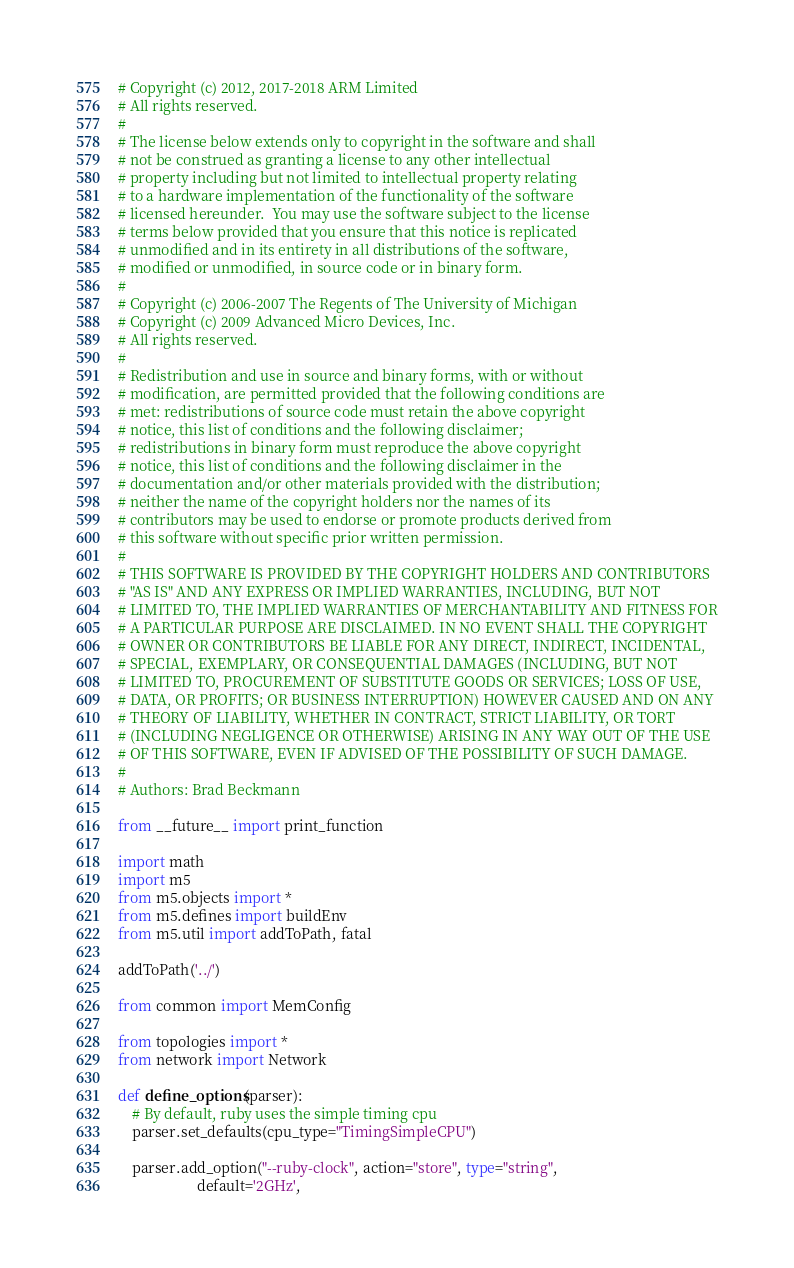Convert code to text. <code><loc_0><loc_0><loc_500><loc_500><_Python_># Copyright (c) 2012, 2017-2018 ARM Limited
# All rights reserved.
#
# The license below extends only to copyright in the software and shall
# not be construed as granting a license to any other intellectual
# property including but not limited to intellectual property relating
# to a hardware implementation of the functionality of the software
# licensed hereunder.  You may use the software subject to the license
# terms below provided that you ensure that this notice is replicated
# unmodified and in its entirety in all distributions of the software,
# modified or unmodified, in source code or in binary form.
#
# Copyright (c) 2006-2007 The Regents of The University of Michigan
# Copyright (c) 2009 Advanced Micro Devices, Inc.
# All rights reserved.
#
# Redistribution and use in source and binary forms, with or without
# modification, are permitted provided that the following conditions are
# met: redistributions of source code must retain the above copyright
# notice, this list of conditions and the following disclaimer;
# redistributions in binary form must reproduce the above copyright
# notice, this list of conditions and the following disclaimer in the
# documentation and/or other materials provided with the distribution;
# neither the name of the copyright holders nor the names of its
# contributors may be used to endorse or promote products derived from
# this software without specific prior written permission.
#
# THIS SOFTWARE IS PROVIDED BY THE COPYRIGHT HOLDERS AND CONTRIBUTORS
# "AS IS" AND ANY EXPRESS OR IMPLIED WARRANTIES, INCLUDING, BUT NOT
# LIMITED TO, THE IMPLIED WARRANTIES OF MERCHANTABILITY AND FITNESS FOR
# A PARTICULAR PURPOSE ARE DISCLAIMED. IN NO EVENT SHALL THE COPYRIGHT
# OWNER OR CONTRIBUTORS BE LIABLE FOR ANY DIRECT, INDIRECT, INCIDENTAL,
# SPECIAL, EXEMPLARY, OR CONSEQUENTIAL DAMAGES (INCLUDING, BUT NOT
# LIMITED TO, PROCUREMENT OF SUBSTITUTE GOODS OR SERVICES; LOSS OF USE,
# DATA, OR PROFITS; OR BUSINESS INTERRUPTION) HOWEVER CAUSED AND ON ANY
# THEORY OF LIABILITY, WHETHER IN CONTRACT, STRICT LIABILITY, OR TORT
# (INCLUDING NEGLIGENCE OR OTHERWISE) ARISING IN ANY WAY OUT OF THE USE
# OF THIS SOFTWARE, EVEN IF ADVISED OF THE POSSIBILITY OF SUCH DAMAGE.
#
# Authors: Brad Beckmann

from __future__ import print_function

import math
import m5
from m5.objects import *
from m5.defines import buildEnv
from m5.util import addToPath, fatal

addToPath('../')

from common import MemConfig

from topologies import *
from network import Network

def define_options(parser):
    # By default, ruby uses the simple timing cpu
    parser.set_defaults(cpu_type="TimingSimpleCPU")

    parser.add_option("--ruby-clock", action="store", type="string",
                      default='2GHz',</code> 